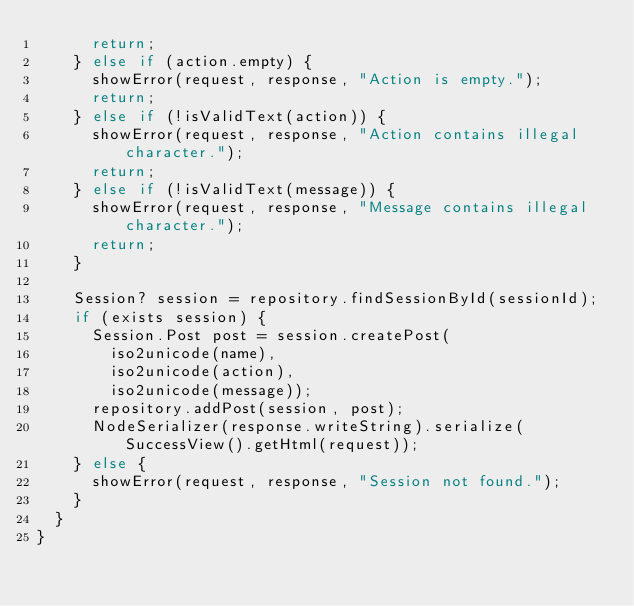<code> <loc_0><loc_0><loc_500><loc_500><_Ceylon_>			return;
		} else if (action.empty) {
			showError(request, response, "Action is empty.");
			return;
		} else if (!isValidText(action)) {
			showError(request, response, "Action contains illegal character.");
			return;
		} else if (!isValidText(message)) {
			showError(request, response, "Message contains illegal character.");
			return;
		}
		
		Session? session = repository.findSessionById(sessionId);
		if (exists session) {
			Session.Post post = session.createPost(
				iso2unicode(name),
				iso2unicode(action),
				iso2unicode(message));
			repository.addPost(session, post);
			NodeSerializer(response.writeString).serialize(SuccessView().getHtml(request));
		} else {
			showError(request, response, "Session not found.");
		}
	}
}
</code> 